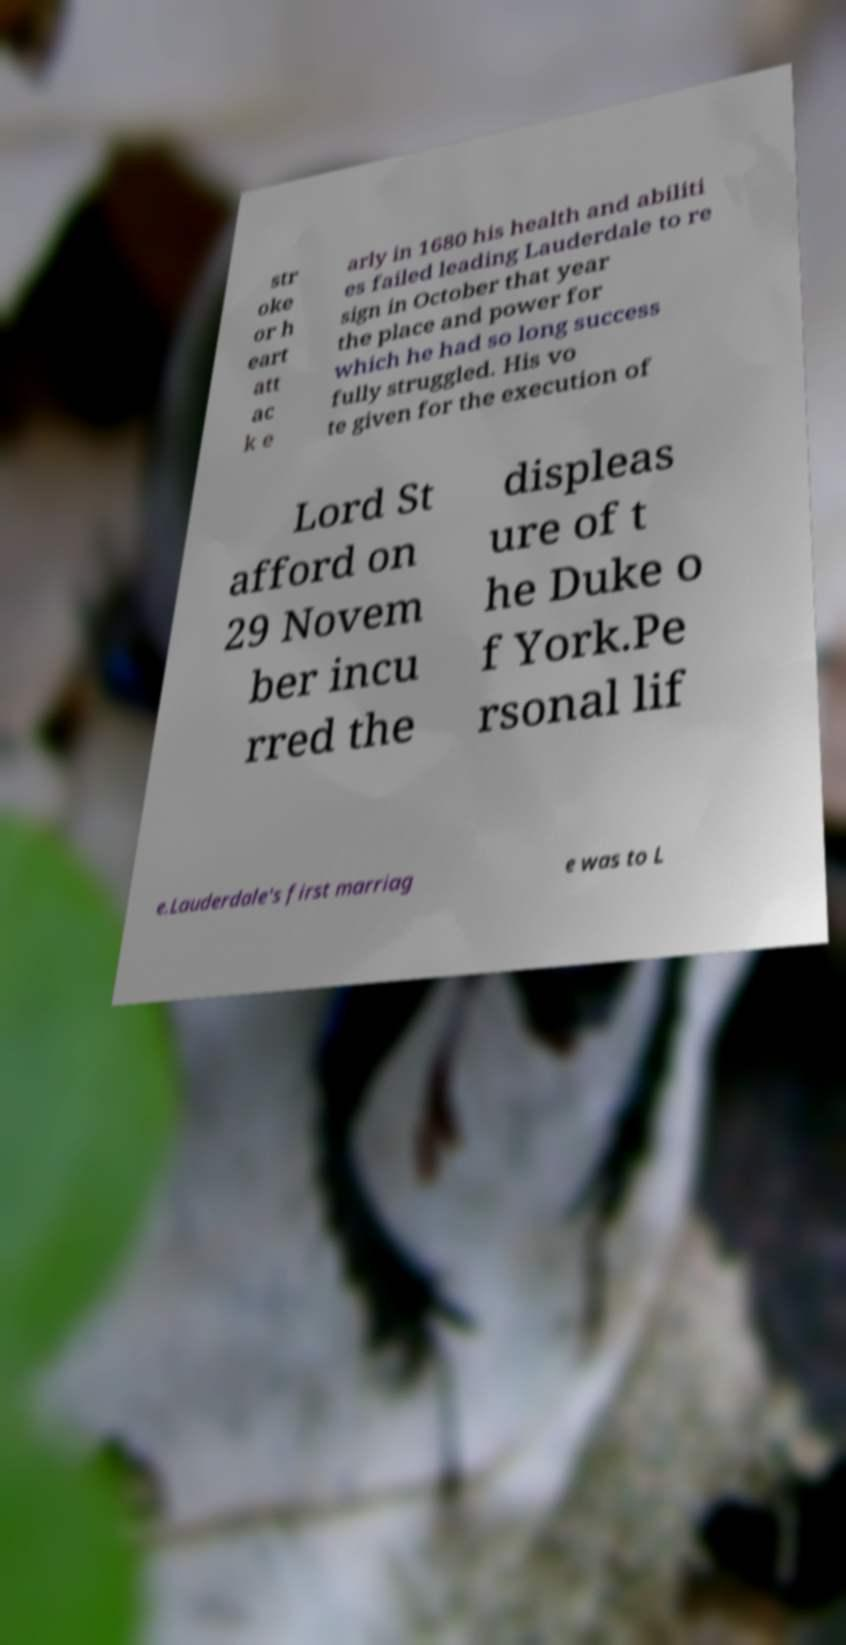Please identify and transcribe the text found in this image. str oke or h eart att ac k e arly in 1680 his health and abiliti es failed leading Lauderdale to re sign in October that year the place and power for which he had so long success fully struggled. His vo te given for the execution of Lord St afford on 29 Novem ber incu rred the displeas ure of t he Duke o f York.Pe rsonal lif e.Lauderdale's first marriag e was to L 